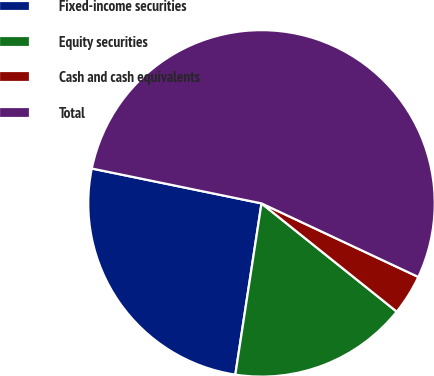Convert chart to OTSL. <chart><loc_0><loc_0><loc_500><loc_500><pie_chart><fcel>Fixed-income securities<fcel>Equity securities<fcel>Cash and cash equivalents<fcel>Total<nl><fcel>25.81%<fcel>16.67%<fcel>3.76%<fcel>53.76%<nl></chart> 